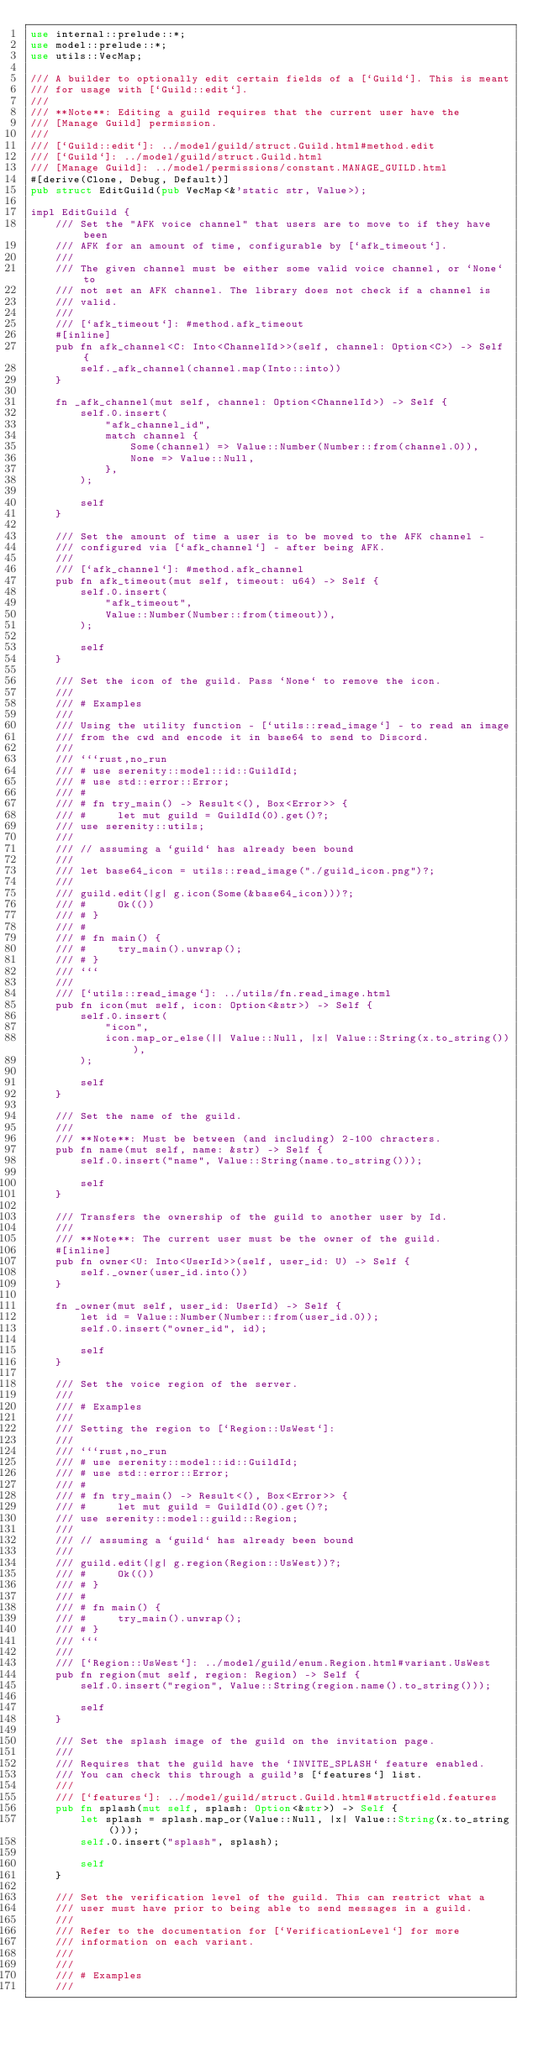<code> <loc_0><loc_0><loc_500><loc_500><_Rust_>use internal::prelude::*;
use model::prelude::*;
use utils::VecMap;

/// A builder to optionally edit certain fields of a [`Guild`]. This is meant
/// for usage with [`Guild::edit`].
///
/// **Note**: Editing a guild requires that the current user have the
/// [Manage Guild] permission.
///
/// [`Guild::edit`]: ../model/guild/struct.Guild.html#method.edit
/// [`Guild`]: ../model/guild/struct.Guild.html
/// [Manage Guild]: ../model/permissions/constant.MANAGE_GUILD.html
#[derive(Clone, Debug, Default)]
pub struct EditGuild(pub VecMap<&'static str, Value>);

impl EditGuild {
    /// Set the "AFK voice channel" that users are to move to if they have been
    /// AFK for an amount of time, configurable by [`afk_timeout`].
    ///
    /// The given channel must be either some valid voice channel, or `None` to
    /// not set an AFK channel. The library does not check if a channel is
    /// valid.
    ///
    /// [`afk_timeout`]: #method.afk_timeout
    #[inline]
    pub fn afk_channel<C: Into<ChannelId>>(self, channel: Option<C>) -> Self {
        self._afk_channel(channel.map(Into::into))
    }

    fn _afk_channel(mut self, channel: Option<ChannelId>) -> Self {
        self.0.insert(
            "afk_channel_id",
            match channel {
                Some(channel) => Value::Number(Number::from(channel.0)),
                None => Value::Null,
            },
        );

        self
    }

    /// Set the amount of time a user is to be moved to the AFK channel -
    /// configured via [`afk_channel`] - after being AFK.
    ///
    /// [`afk_channel`]: #method.afk_channel
    pub fn afk_timeout(mut self, timeout: u64) -> Self {
        self.0.insert(
            "afk_timeout",
            Value::Number(Number::from(timeout)),
        );

        self
    }

    /// Set the icon of the guild. Pass `None` to remove the icon.
    ///
    /// # Examples
    ///
    /// Using the utility function - [`utils::read_image`] - to read an image
    /// from the cwd and encode it in base64 to send to Discord.
    ///
    /// ```rust,no_run
    /// # use serenity::model::id::GuildId;
    /// # use std::error::Error;
    /// #
    /// # fn try_main() -> Result<(), Box<Error>> {
    /// #     let mut guild = GuildId(0).get()?;
    /// use serenity::utils;
    ///
    /// // assuming a `guild` has already been bound
    ///
    /// let base64_icon = utils::read_image("./guild_icon.png")?;
    ///
    /// guild.edit(|g| g.icon(Some(&base64_icon)))?;
    /// #     Ok(())
    /// # }
    /// #
    /// # fn main() {
    /// #     try_main().unwrap();
    /// # }
    /// ```
    ///
    /// [`utils::read_image`]: ../utils/fn.read_image.html
    pub fn icon(mut self, icon: Option<&str>) -> Self {
        self.0.insert(
            "icon",
            icon.map_or_else(|| Value::Null, |x| Value::String(x.to_string())),
        );

        self
    }

    /// Set the name of the guild.
    ///
    /// **Note**: Must be between (and including) 2-100 chracters.
    pub fn name(mut self, name: &str) -> Self {
        self.0.insert("name", Value::String(name.to_string()));

        self
    }

    /// Transfers the ownership of the guild to another user by Id.
    ///
    /// **Note**: The current user must be the owner of the guild.
    #[inline]
    pub fn owner<U: Into<UserId>>(self, user_id: U) -> Self {
        self._owner(user_id.into())
    }

    fn _owner(mut self, user_id: UserId) -> Self {
        let id = Value::Number(Number::from(user_id.0));
        self.0.insert("owner_id", id);

        self
    }

    /// Set the voice region of the server.
    ///
    /// # Examples
    ///
    /// Setting the region to [`Region::UsWest`]:
    ///
    /// ```rust,no_run
    /// # use serenity::model::id::GuildId;
    /// # use std::error::Error;
    /// #
    /// # fn try_main() -> Result<(), Box<Error>> {
    /// #     let mut guild = GuildId(0).get()?;
    /// use serenity::model::guild::Region;
    ///
    /// // assuming a `guild` has already been bound
    ///
    /// guild.edit(|g| g.region(Region::UsWest))?;
    /// #     Ok(())
    /// # }
    /// #
    /// # fn main() {
    /// #     try_main().unwrap();
    /// # }
    /// ```
    ///
    /// [`Region::UsWest`]: ../model/guild/enum.Region.html#variant.UsWest
    pub fn region(mut self, region: Region) -> Self {
        self.0.insert("region", Value::String(region.name().to_string()));

        self
    }

    /// Set the splash image of the guild on the invitation page.
    ///
    /// Requires that the guild have the `INVITE_SPLASH` feature enabled.
    /// You can check this through a guild's [`features`] list.
    ///
    /// [`features`]: ../model/guild/struct.Guild.html#structfield.features
    pub fn splash(mut self, splash: Option<&str>) -> Self {
        let splash = splash.map_or(Value::Null, |x| Value::String(x.to_string()));
        self.0.insert("splash", splash);

        self
    }

    /// Set the verification level of the guild. This can restrict what a
    /// user must have prior to being able to send messages in a guild.
    ///
    /// Refer to the documentation for [`VerificationLevel`] for more
    /// information on each variant.
    ///
    ///
    /// # Examples
    ///</code> 